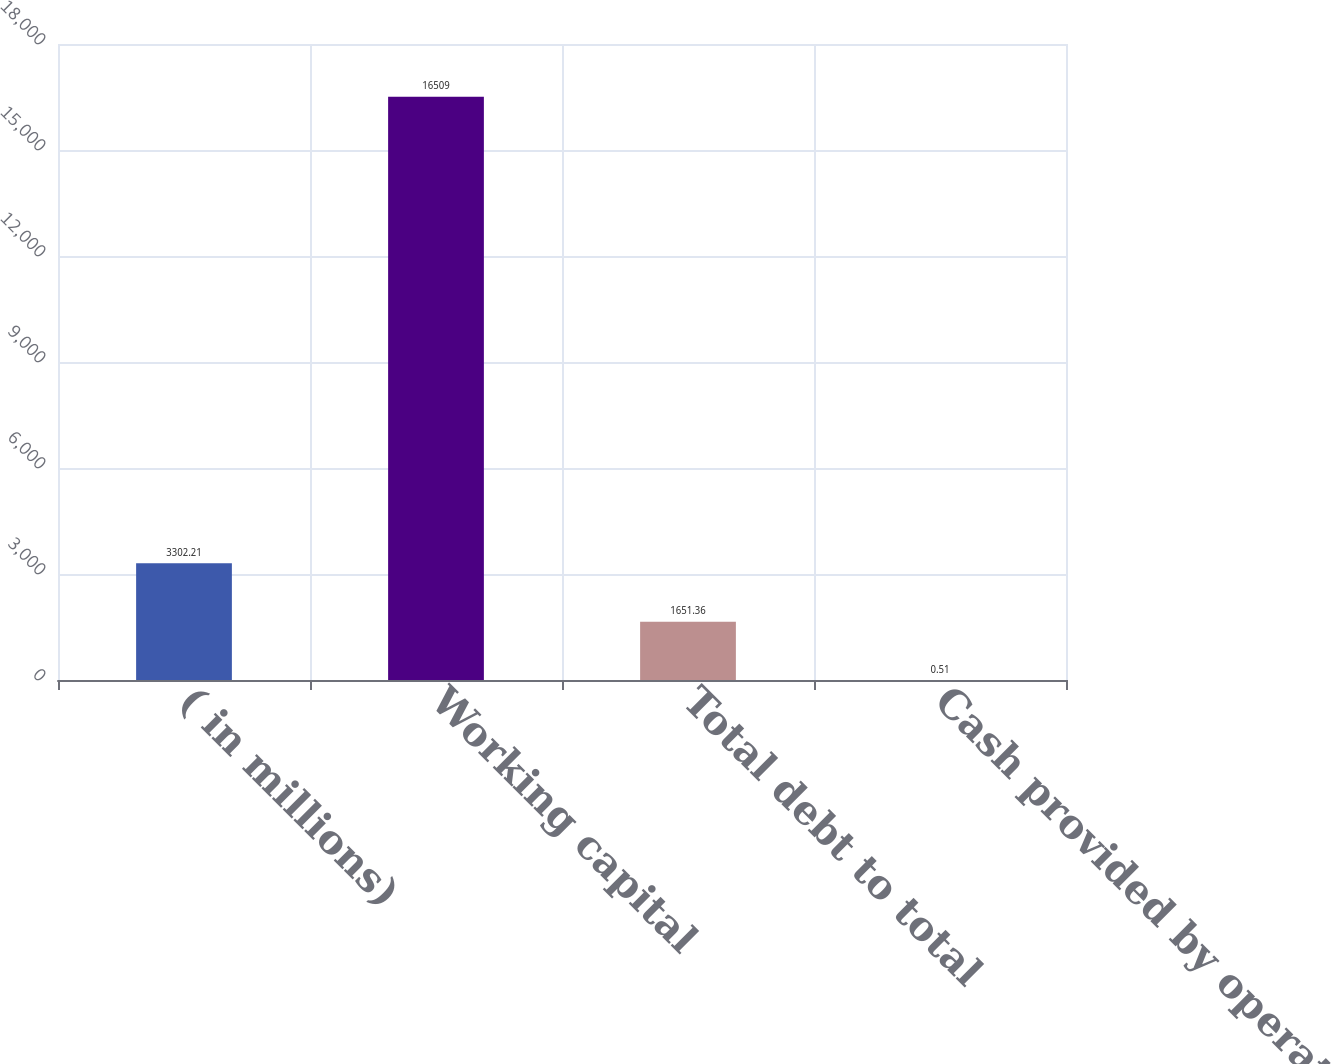Convert chart to OTSL. <chart><loc_0><loc_0><loc_500><loc_500><bar_chart><fcel>( in millions)<fcel>Working capital<fcel>Total debt to total<fcel>Cash provided by operations to<nl><fcel>3302.21<fcel>16509<fcel>1651.36<fcel>0.51<nl></chart> 